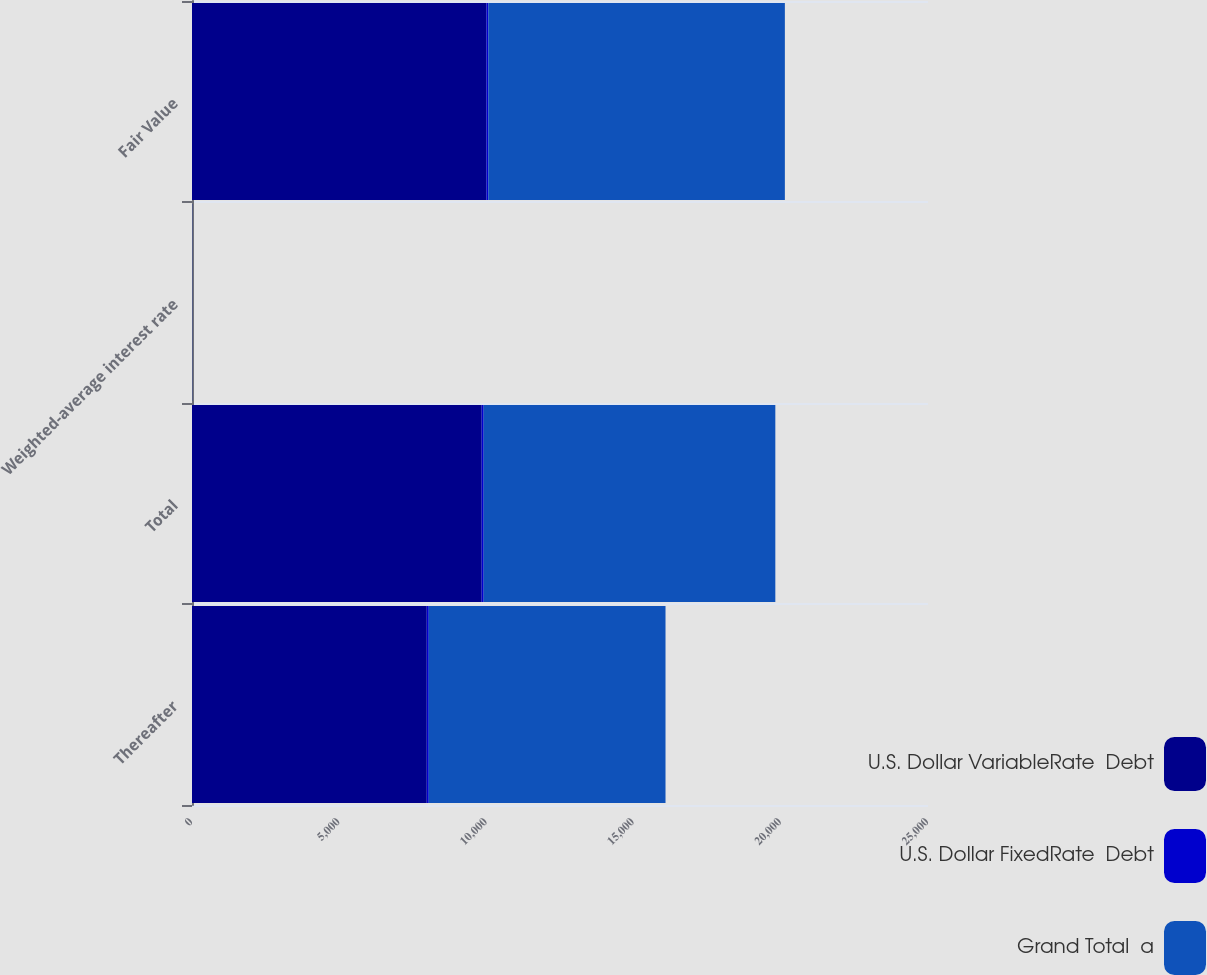Convert chart. <chart><loc_0><loc_0><loc_500><loc_500><stacked_bar_chart><ecel><fcel>Thereafter<fcel>Total<fcel>Weighted-average interest rate<fcel>Fair Value<nl><fcel>U.S. Dollar VariableRate  Debt<fcel>7974<fcel>9839<fcel>3.67<fcel>10001<nl><fcel>U.S. Dollar FixedRate  Debt<fcel>68<fcel>68<fcel>0.9<fcel>68<nl><fcel>Grand Total  a<fcel>8042<fcel>9907<fcel>3.65<fcel>10069<nl></chart> 